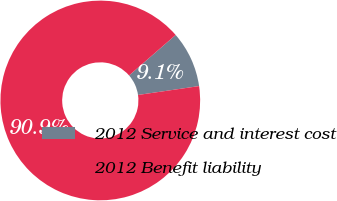Convert chart. <chart><loc_0><loc_0><loc_500><loc_500><pie_chart><fcel>2012 Service and interest cost<fcel>2012 Benefit liability<nl><fcel>9.09%<fcel>90.91%<nl></chart> 